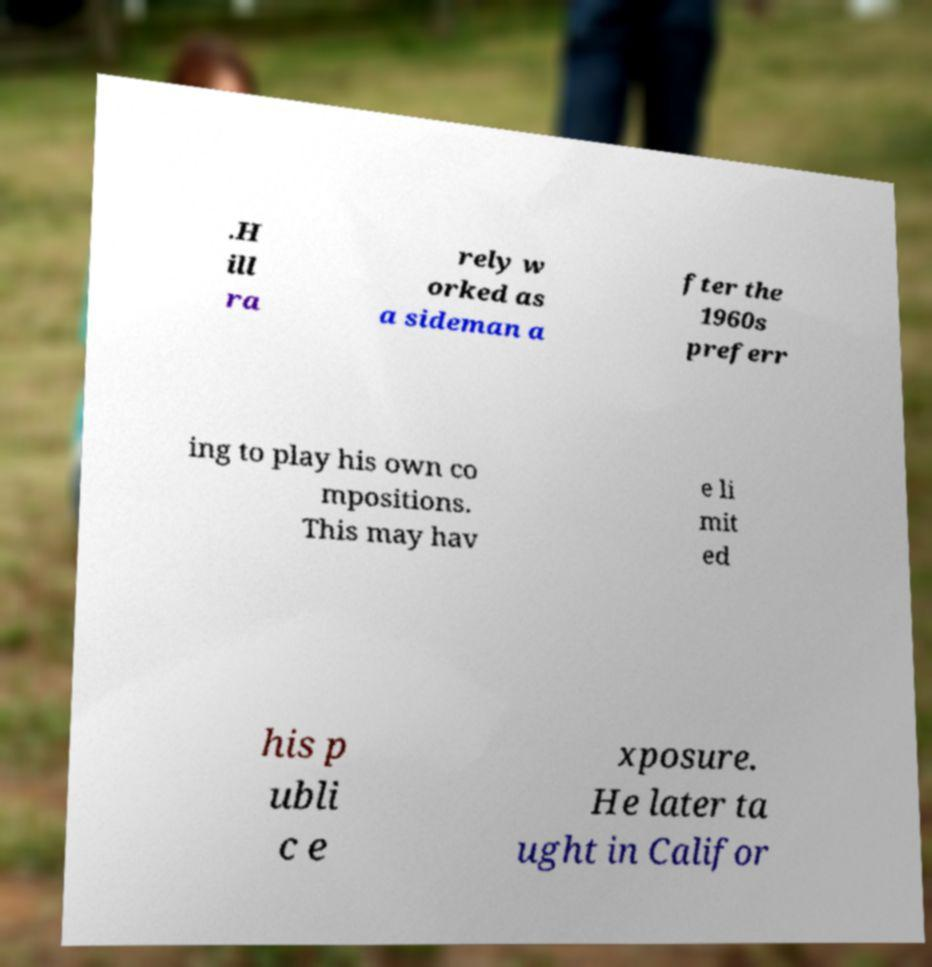Could you extract and type out the text from this image? .H ill ra rely w orked as a sideman a fter the 1960s preferr ing to play his own co mpositions. This may hav e li mit ed his p ubli c e xposure. He later ta ught in Califor 